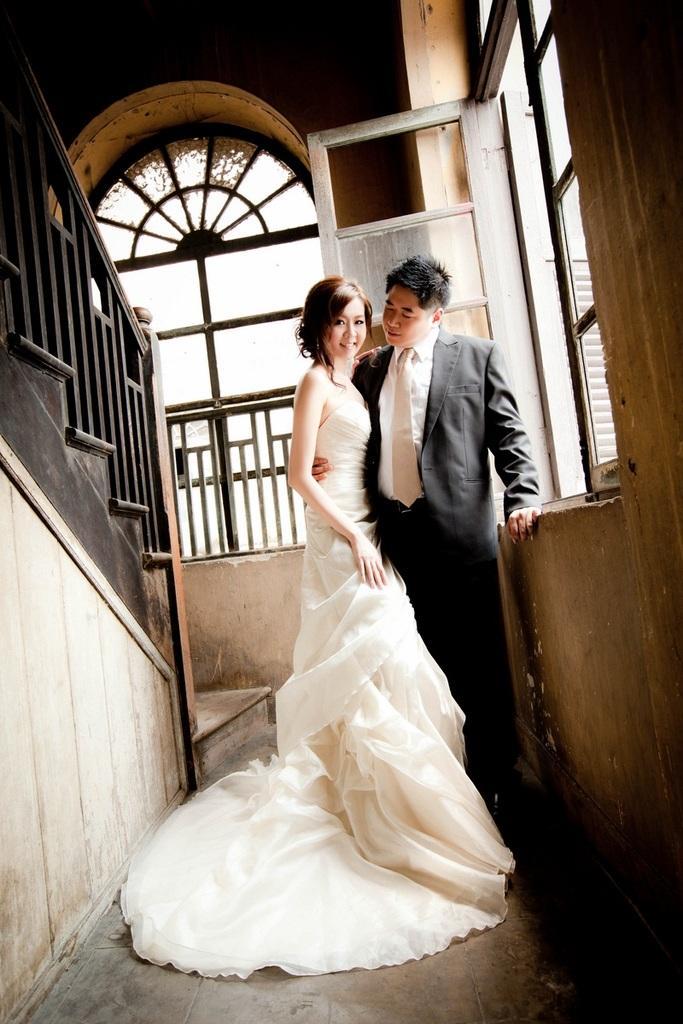Can you describe this image briefly? In the middle of the image I can see a woman and man. In this image there are windows, railing and walls.  